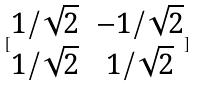<formula> <loc_0><loc_0><loc_500><loc_500>[ \begin{matrix} 1 / \sqrt { 2 } & - 1 / \sqrt { 2 } \\ 1 / \sqrt { 2 } & 1 / \sqrt { 2 } \end{matrix} ]</formula> 